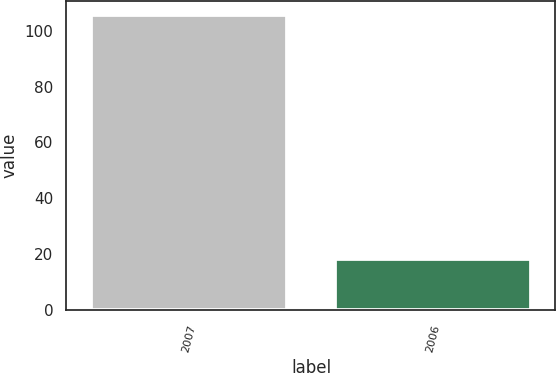Convert chart. <chart><loc_0><loc_0><loc_500><loc_500><bar_chart><fcel>2007<fcel>2006<nl><fcel>105.4<fcel>18.3<nl></chart> 